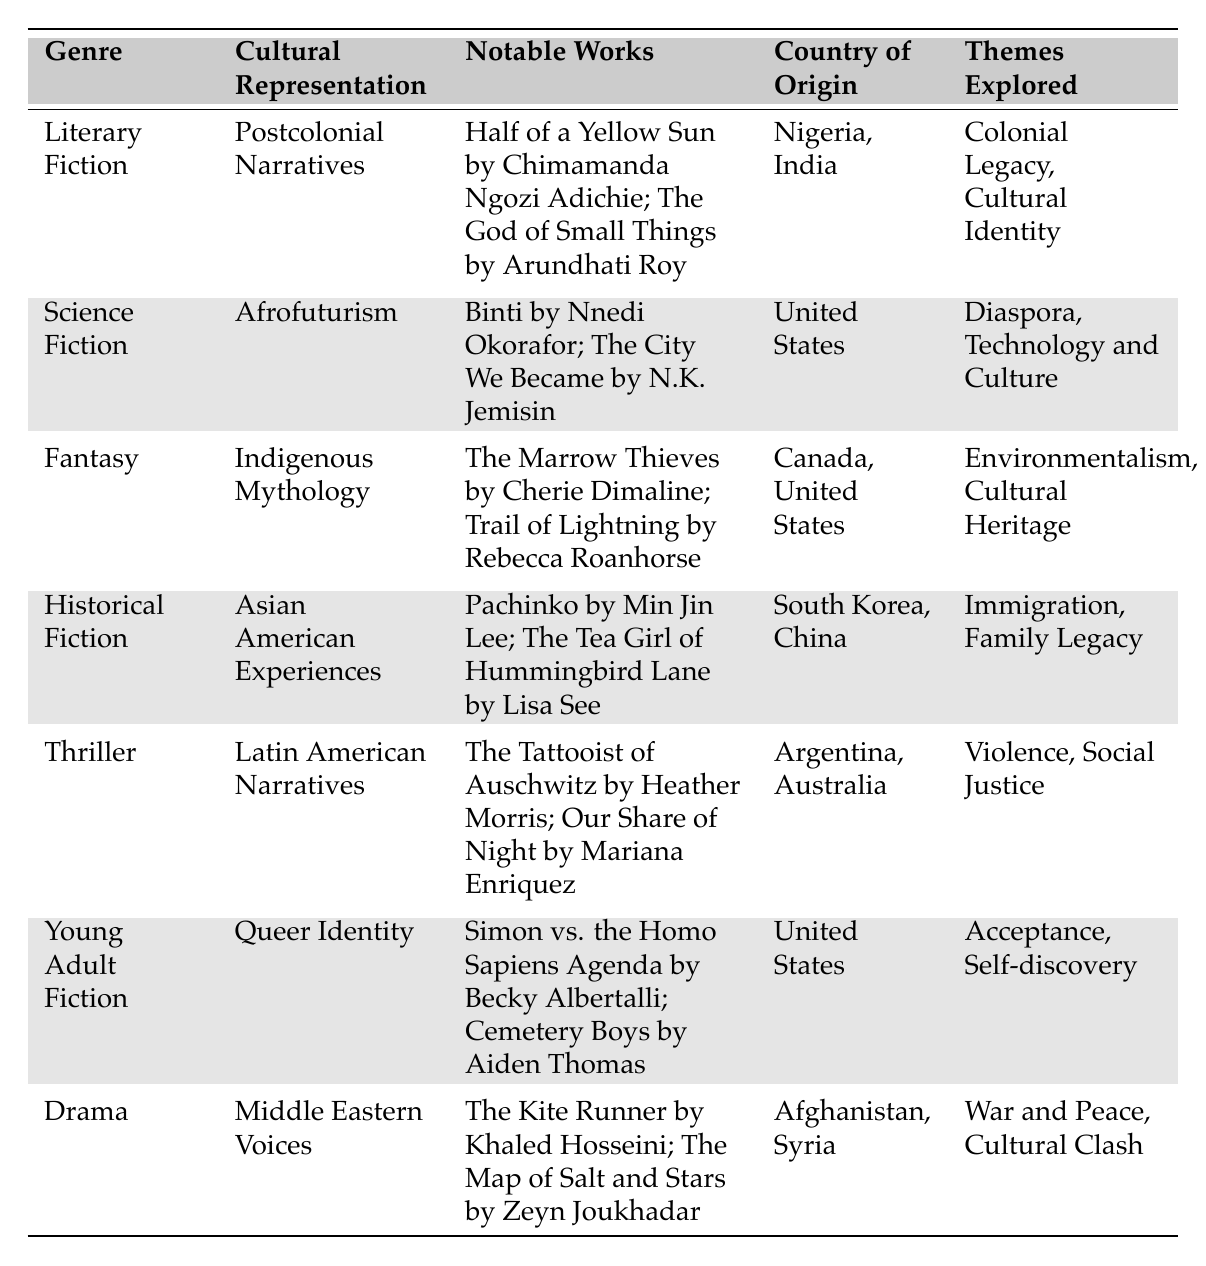What genre focuses on Postcolonial Narratives? The table lists "Literary Fiction" as the genre associated with Postcolonial Narratives.
Answer: Literary Fiction Which country is associated with the notable work "Pachinko"? The table indicates that "Pachinko" is associated with South Korea as part of the country of origin.
Answer: South Korea Name one theme explored in Afrofuturism within Science Fiction. The table shows that one of the themes explored in Afrofuturism is "Diaspora."
Answer: Diaspora Is "Cemetery Boys" categorized under Thriller? The table clearly categorizes "Cemetery Boys" under Young Adult Fiction, not Thriller.
Answer: No Which genre has notable works focusing on Environmentalism? "Fantasy" is indicated as the genre that explores the theme of Environmentalism through its notable works.
Answer: Fantasy How many genres explore themes related to social justice? In the table, "Thriller" explores "Social Justice," and that is the only genre listed with this theme.
Answer: 1 List two notable works under Middle Eastern Voices in Drama. The table provides two notable works: "The Kite Runner" and "The Map of Salt and Stars" under Middle Eastern Voices.
Answer: The Kite Runner; The Map of Salt and Stars Which country of origin is associated with both "The Marrow Thieves" and "Trail of Lightning"? Both works are noted as originating from Canada and the United States in the table.
Answer: Canada, United States How many themes are explored in Historical Fiction? The table lists two themes under Historical Fiction: "Immigration" and "Family Legacy."
Answer: 2 Is there a genre that represents Queer Identity in the United States? Yes, the table indicates that Young Adult Fiction represents Queer Identity, specifically from the United States.
Answer: Yes What themes are associated with the notable works in Latin American Narratives? The table mentions that "Violence" and "Social Justice" are themes explored in the context of Latin American Narratives.
Answer: Violence, Social Justice 